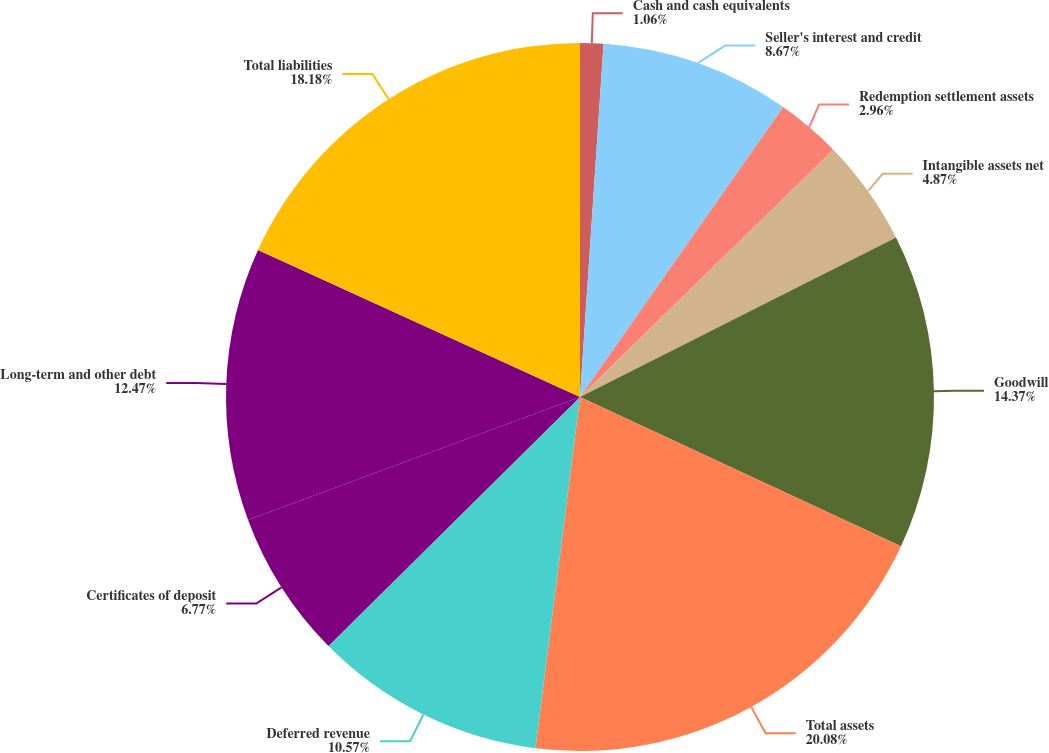Convert chart. <chart><loc_0><loc_0><loc_500><loc_500><pie_chart><fcel>Cash and cash equivalents<fcel>Seller's interest and credit<fcel>Redemption settlement assets<fcel>Intangible assets net<fcel>Goodwill<fcel>Total assets<fcel>Deferred revenue<fcel>Certificates of deposit<fcel>Long-term and other debt<fcel>Total liabilities<nl><fcel>1.06%<fcel>8.67%<fcel>2.96%<fcel>4.87%<fcel>14.37%<fcel>20.08%<fcel>10.57%<fcel>6.77%<fcel>12.47%<fcel>18.18%<nl></chart> 